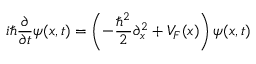<formula> <loc_0><loc_0><loc_500><loc_500>i \hbar { } \partial } { \partial t } \psi ( x , t ) = \left ( - \frac { \hbar { ^ } { 2 } } { 2 } \partial _ { x } ^ { 2 } + V _ { F } ( x ) \right ) \psi ( x , t )</formula> 